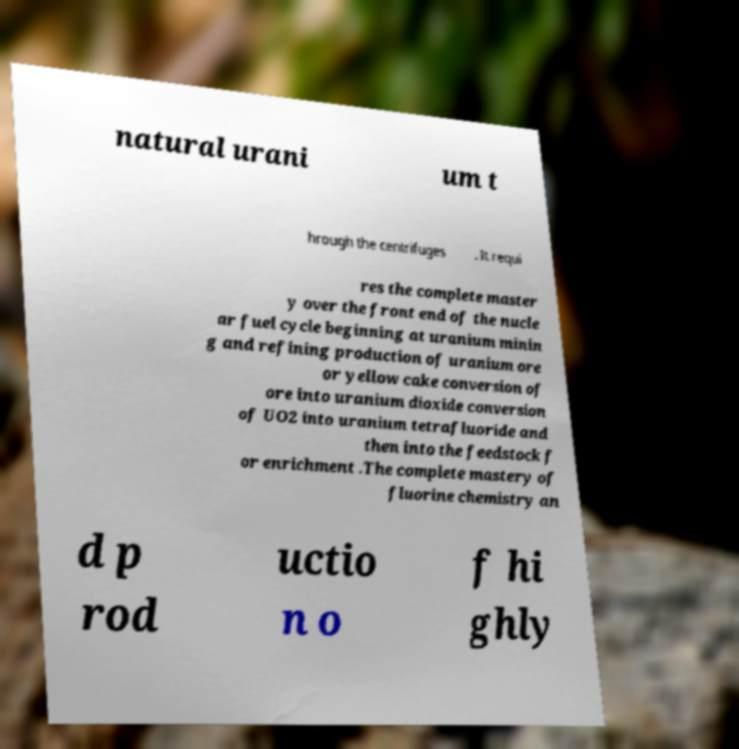I need the written content from this picture converted into text. Can you do that? natural urani um t hrough the centrifuges . It requi res the complete master y over the front end of the nucle ar fuel cycle beginning at uranium minin g and refining production of uranium ore or yellow cake conversion of ore into uranium dioxide conversion of UO2 into uranium tetrafluoride and then into the feedstock f or enrichment .The complete mastery of fluorine chemistry an d p rod uctio n o f hi ghly 